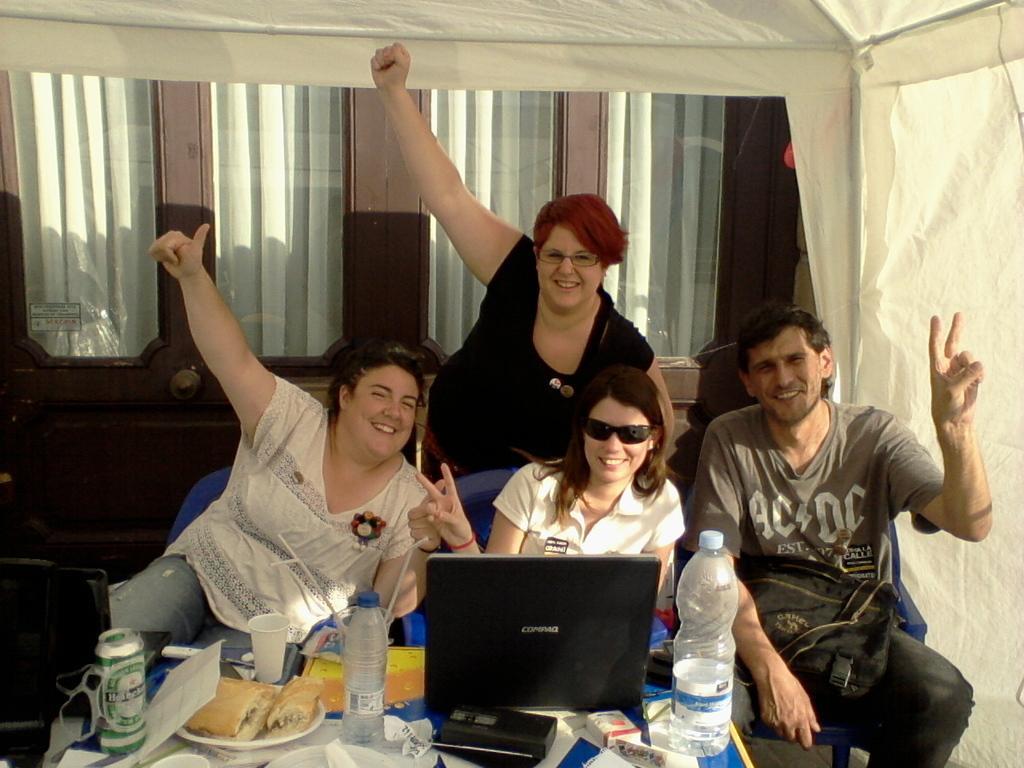How would you summarize this image in a sentence or two? In this image I can see there are four persons , they are smiling and they are sitting on chairs and one person standing backside of them I can see window and curtain and in front of them there is a table, on the table there are bottles, glass, coke tin ,tissues, plates, on plates I can see bread pieces all are kept on table. 